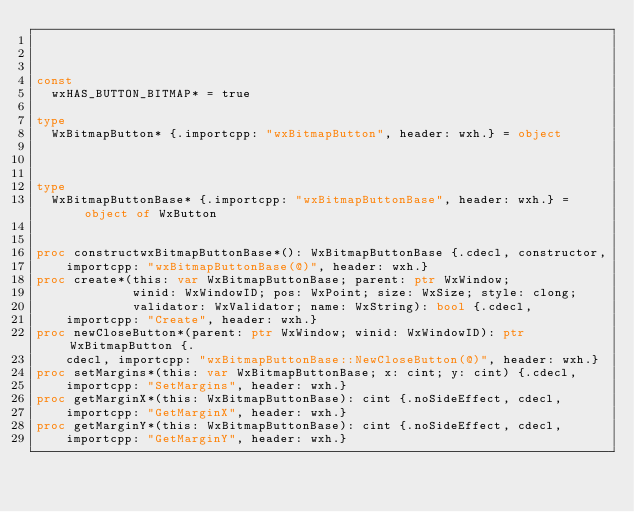Convert code to text. <code><loc_0><loc_0><loc_500><loc_500><_Nim_>


const 
  wxHAS_BUTTON_BITMAP* = true

type 
  WxBitmapButton* {.importcpp: "wxBitmapButton", header: wxh.} = object 
  


type 
  WxBitmapButtonBase* {.importcpp: "wxBitmapButtonBase", header: wxh.} = object of WxButton
  

proc constructwxBitmapButtonBase*(): WxBitmapButtonBase {.cdecl, constructor, 
    importcpp: "wxBitmapButtonBase(@)", header: wxh.}
proc create*(this: var WxBitmapButtonBase; parent: ptr WxWindow; 
             winid: WxWindowID; pos: WxPoint; size: WxSize; style: clong; 
             validator: WxValidator; name: WxString): bool {.cdecl, 
    importcpp: "Create", header: wxh.}
proc newCloseButton*(parent: ptr WxWindow; winid: WxWindowID): ptr WxBitmapButton {.
    cdecl, importcpp: "wxBitmapButtonBase::NewCloseButton(@)", header: wxh.}
proc setMargins*(this: var WxBitmapButtonBase; x: cint; y: cint) {.cdecl, 
    importcpp: "SetMargins", header: wxh.}
proc getMarginX*(this: WxBitmapButtonBase): cint {.noSideEffect, cdecl, 
    importcpp: "GetMarginX", header: wxh.}
proc getMarginY*(this: WxBitmapButtonBase): cint {.noSideEffect, cdecl, 
    importcpp: "GetMarginY", header: wxh.}</code> 